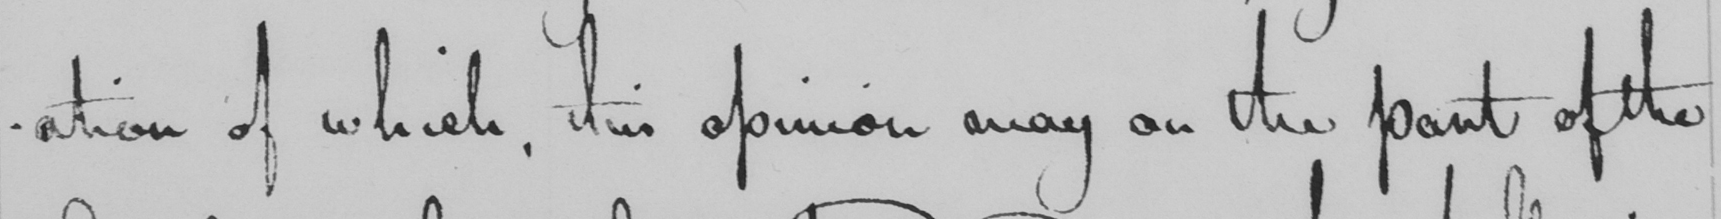Can you tell me what this handwritten text says? -ation of which, this opinion may on the part of the 